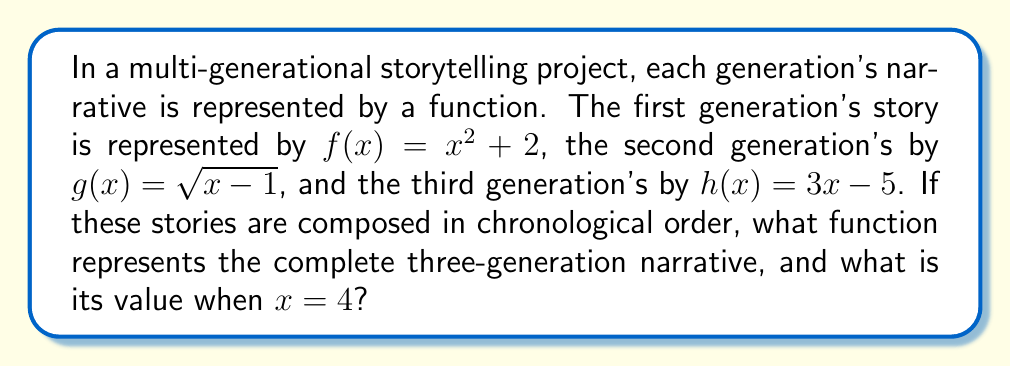What is the answer to this math problem? To solve this problem, we need to compose the functions in the order they occur:

1) First, we start with the first generation's story: $f(x) = x^2 + 2$

2) The second generation's story is applied to the result of the first: $g(f(x))$
   $g(f(x)) = \sqrt{f(x) - 1} = \sqrt{(x^2 + 2) - 1} = \sqrt{x^2 + 1}$

3) Finally, the third generation's story is applied to the result of the first two: $h(g(f(x)))$
   $h(g(f(x))) = 3(\sqrt{x^2 + 1}) - 5$

This gives us the complete three-generation narrative function.

To find its value when $x = 4$:

$h(g(f(4))) = 3(\sqrt{4^2 + 1}) - 5$
            $= 3(\sqrt{16 + 1}) - 5$
            $= 3(\sqrt{17}) - 5$
            $= 3 \cdot 4.123105... - 5$
            $= 12.369315... - 5$
            $= 7.369315...$
Answer: The function representing the complete three-generation narrative is $h(g(f(x))) = 3(\sqrt{x^2 + 1}) - 5$, and its value when $x = 4$ is approximately $7.369315$. 